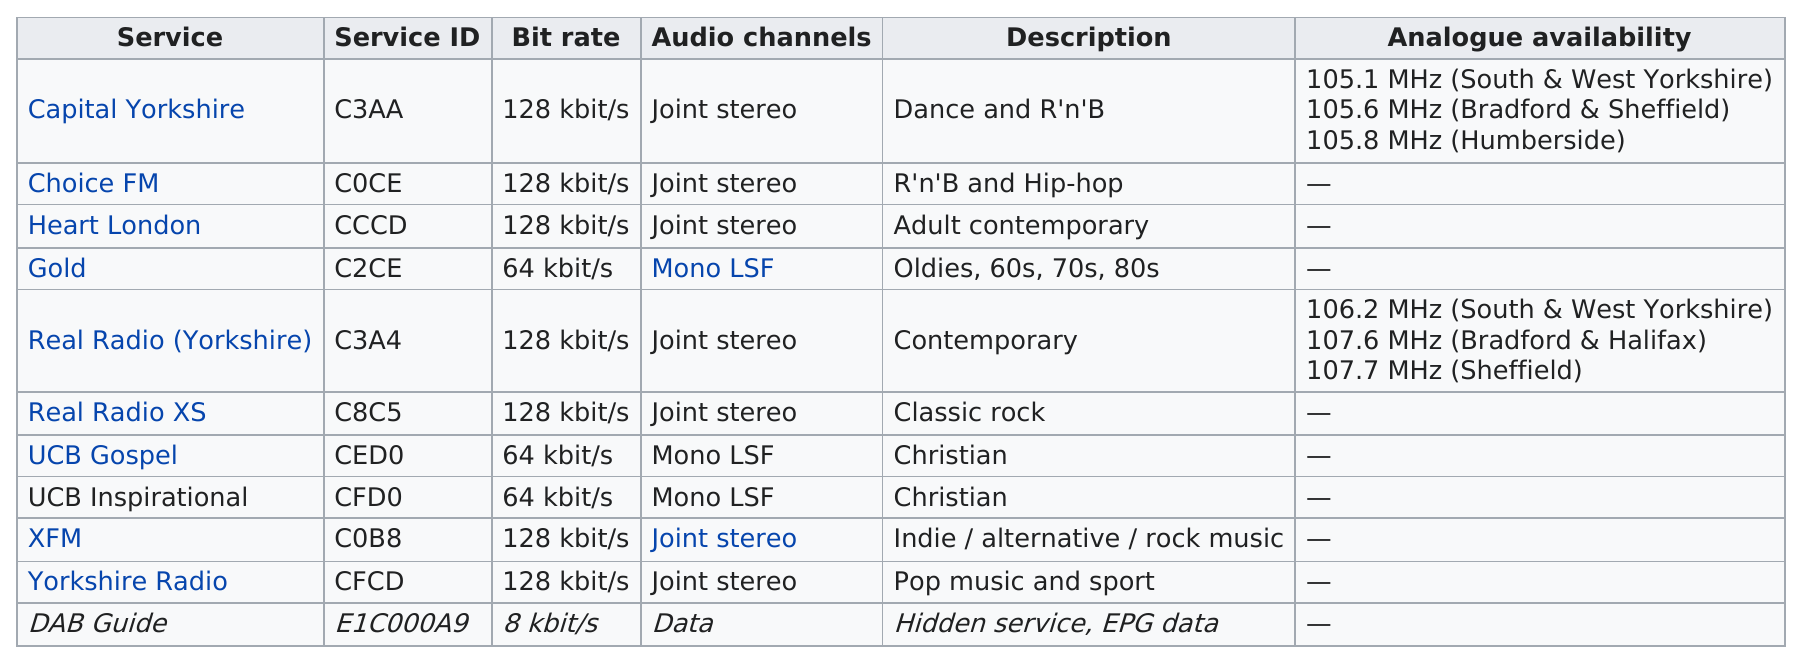Indicate a few pertinent items in this graphic. Heart London broadcasts adult contemporary music, as well as R'n'B and hip-hop. The only indie/alternative/rock music radio station broadcasted by MXR Yorkshire is XFM. There are three different analogues available for Capital Yorkshire. The service being described is a dance and R&B service with a bit rate of Kbit/s, located in Capital Yorkshire. Seven stations have a data rate of at least 128 kilobits per second. 